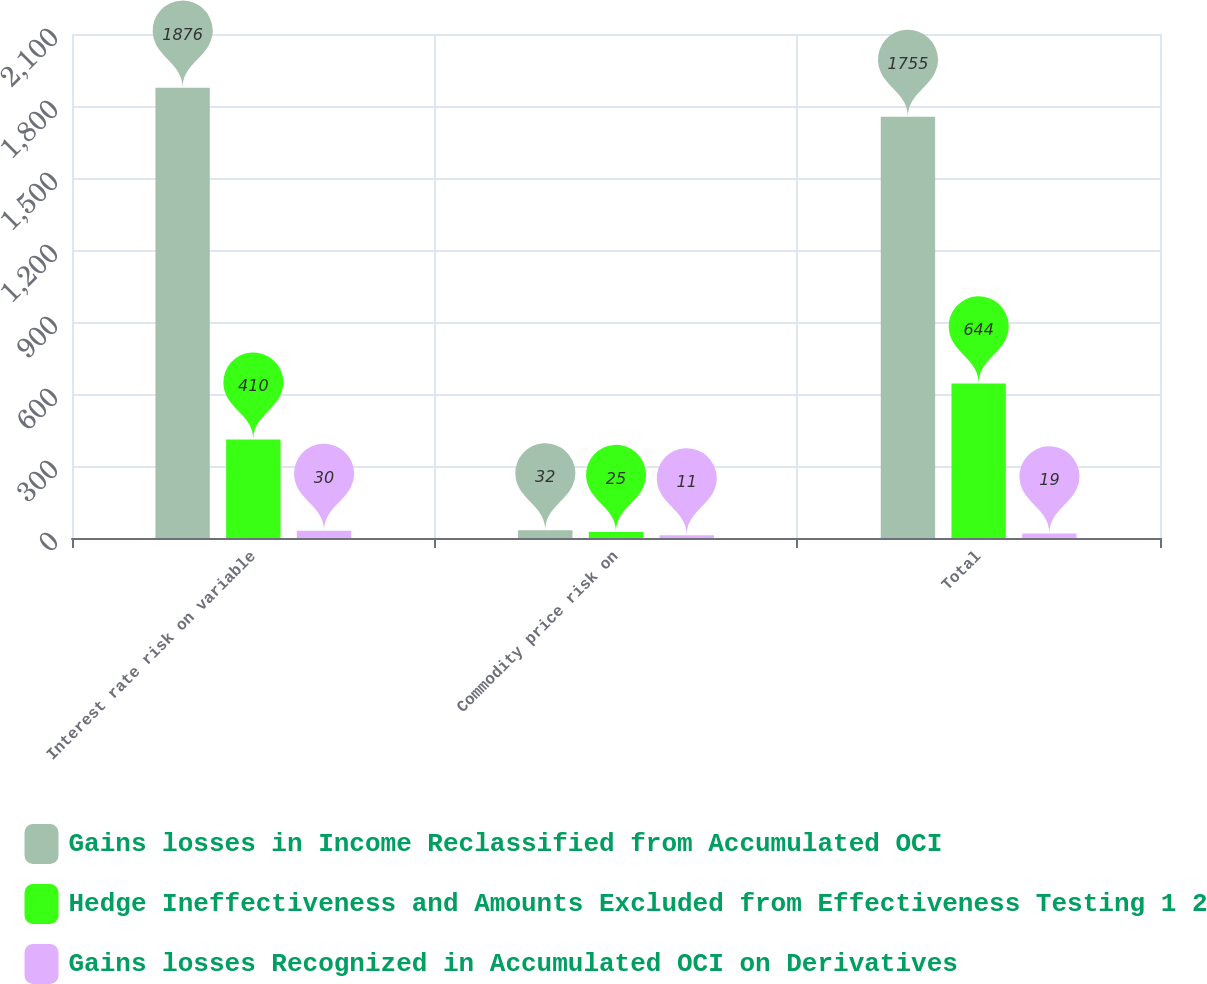Convert chart. <chart><loc_0><loc_0><loc_500><loc_500><stacked_bar_chart><ecel><fcel>Interest rate risk on variable<fcel>Commodity price risk on<fcel>Total<nl><fcel>Gains losses in Income Reclassified from Accumulated OCI<fcel>1876<fcel>32<fcel>1755<nl><fcel>Hedge Ineffectiveness and Amounts Excluded from Effectiveness Testing 1 2<fcel>410<fcel>25<fcel>644<nl><fcel>Gains losses Recognized in Accumulated OCI on Derivatives<fcel>30<fcel>11<fcel>19<nl></chart> 